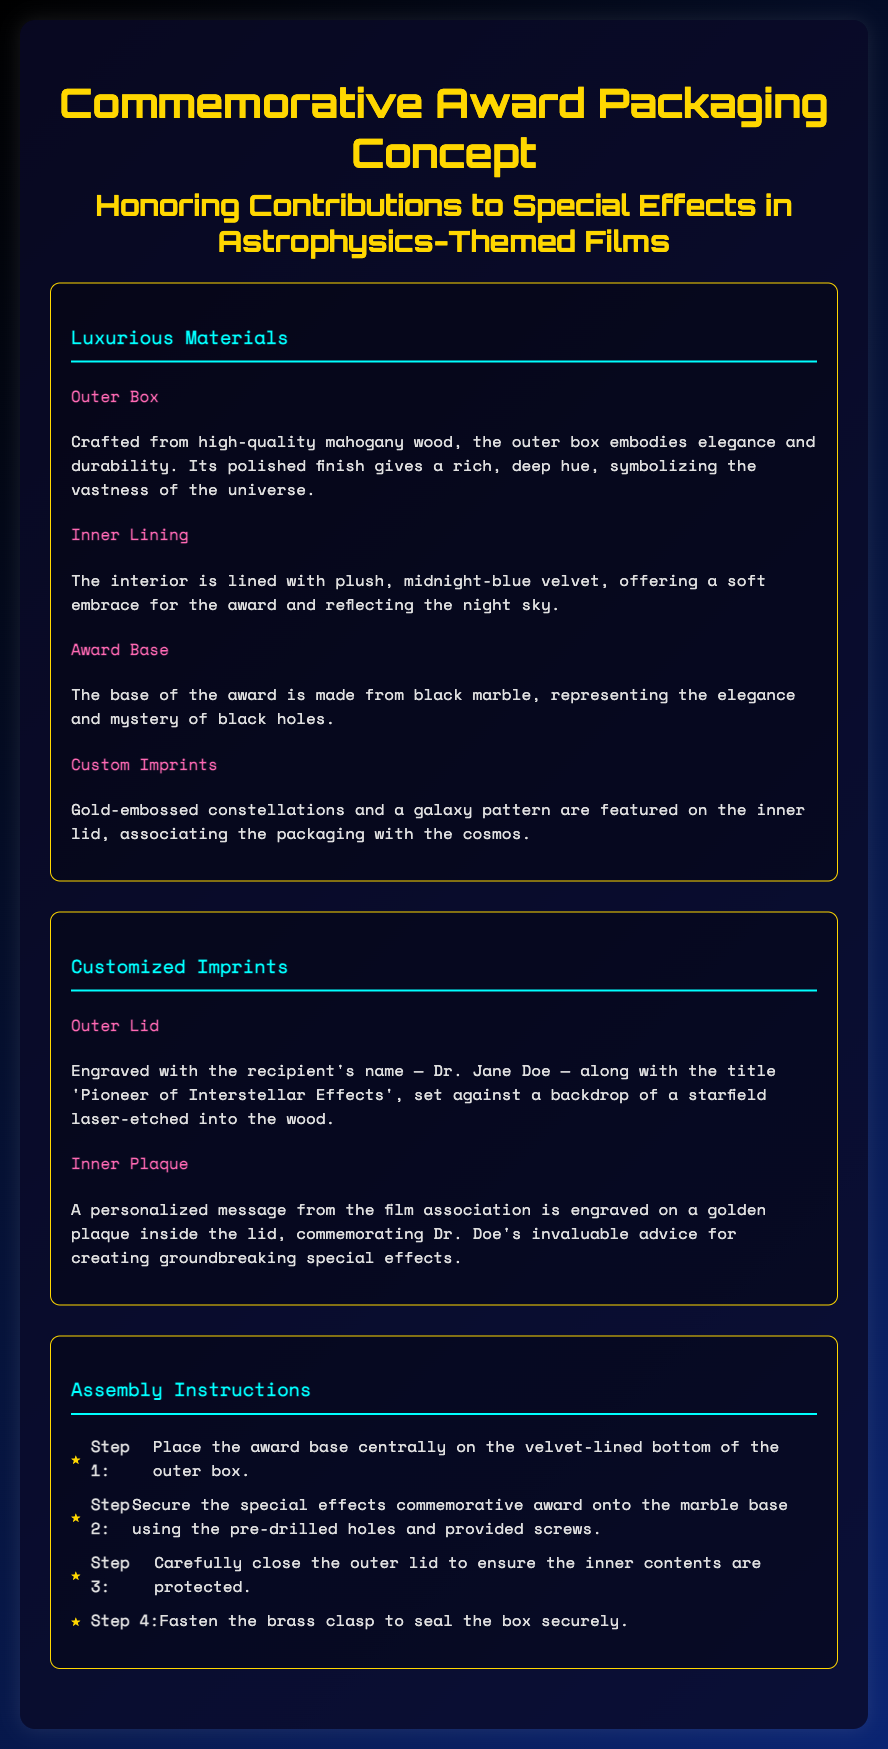What is the outer box made of? The outer box is crafted from high-quality mahogany wood, providing elegance and durability.
Answer: Mahogany wood What color is the inner lining? The interior is lined with plush, midnight-blue velvet, resembling the night sky.
Answer: Midnight-blue Who is the recipient of the award? The recipient's name is engraved on the outer lid of the box.
Answer: Dr. Jane Doe What material is the award base made of? The base of the award is made from black marble, which is mentioned as elegant and mysterious.
Answer: Black marble How many assembly steps are provided in the instructions? The instructions list steps needed to assemble the award, which requires counting the items.
Answer: Four steps 